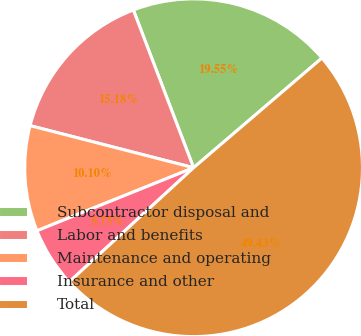Convert chart to OTSL. <chart><loc_0><loc_0><loc_500><loc_500><pie_chart><fcel>Subcontractor disposal and<fcel>Labor and benefits<fcel>Maintenance and operating<fcel>Insurance and other<fcel>Total<nl><fcel>19.55%<fcel>15.18%<fcel>10.1%<fcel>5.73%<fcel>49.43%<nl></chart> 